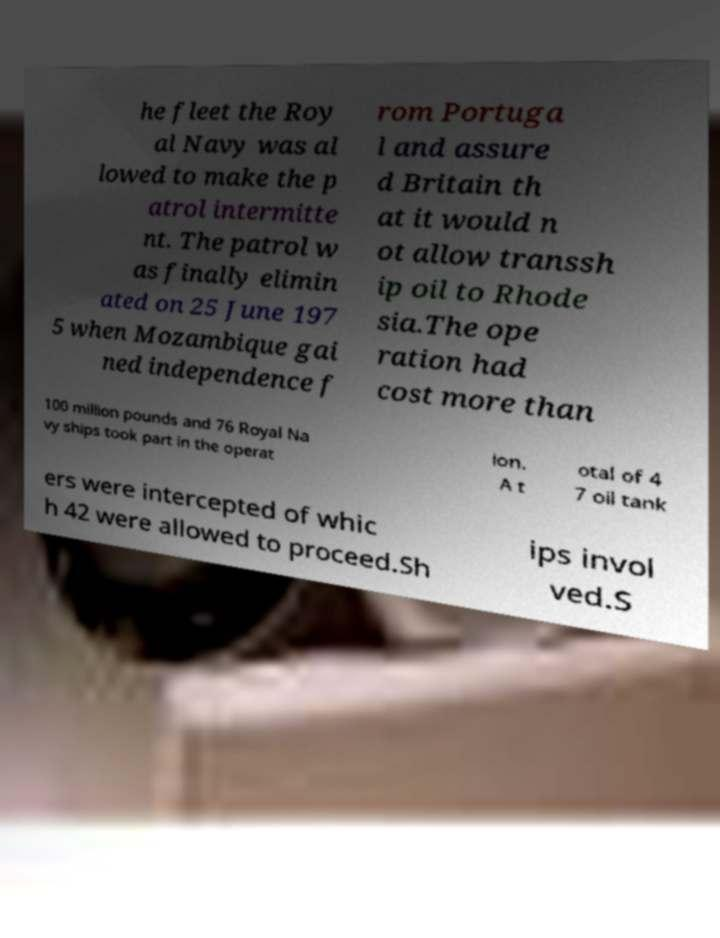Please identify and transcribe the text found in this image. he fleet the Roy al Navy was al lowed to make the p atrol intermitte nt. The patrol w as finally elimin ated on 25 June 197 5 when Mozambique gai ned independence f rom Portuga l and assure d Britain th at it would n ot allow transsh ip oil to Rhode sia.The ope ration had cost more than 100 million pounds and 76 Royal Na vy ships took part in the operat ion. A t otal of 4 7 oil tank ers were intercepted of whic h 42 were allowed to proceed.Sh ips invol ved.S 